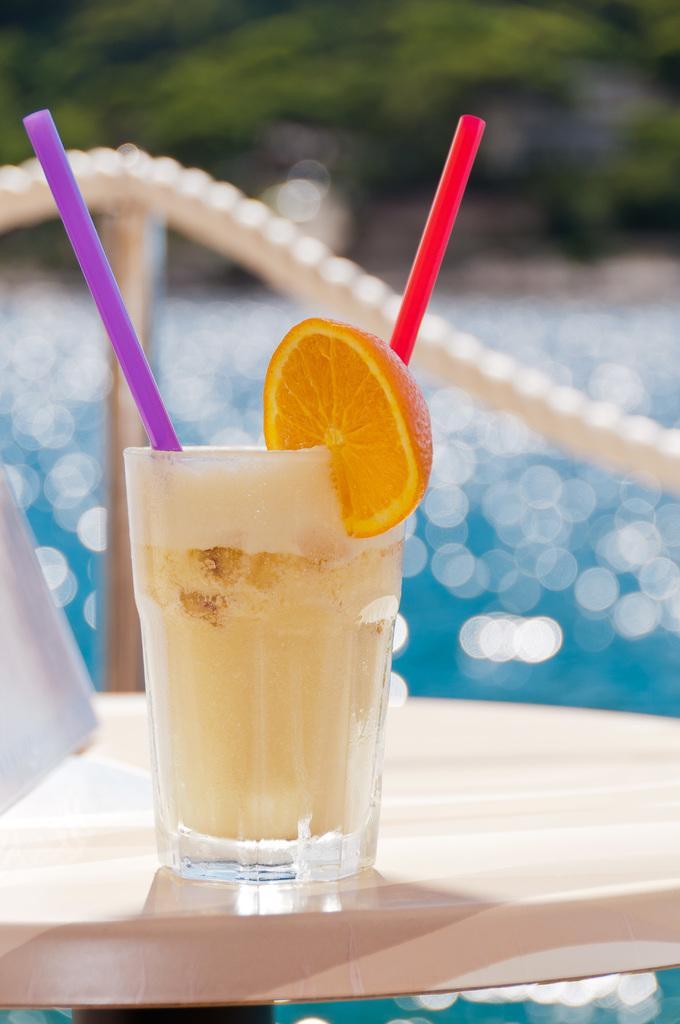Please provide a concise description of this image. In this picture we can see a glass with some liquid and straws. On the glass there is a lemon slice and the glass is on the table. Behind the glass they look like a rope, water and trees. 